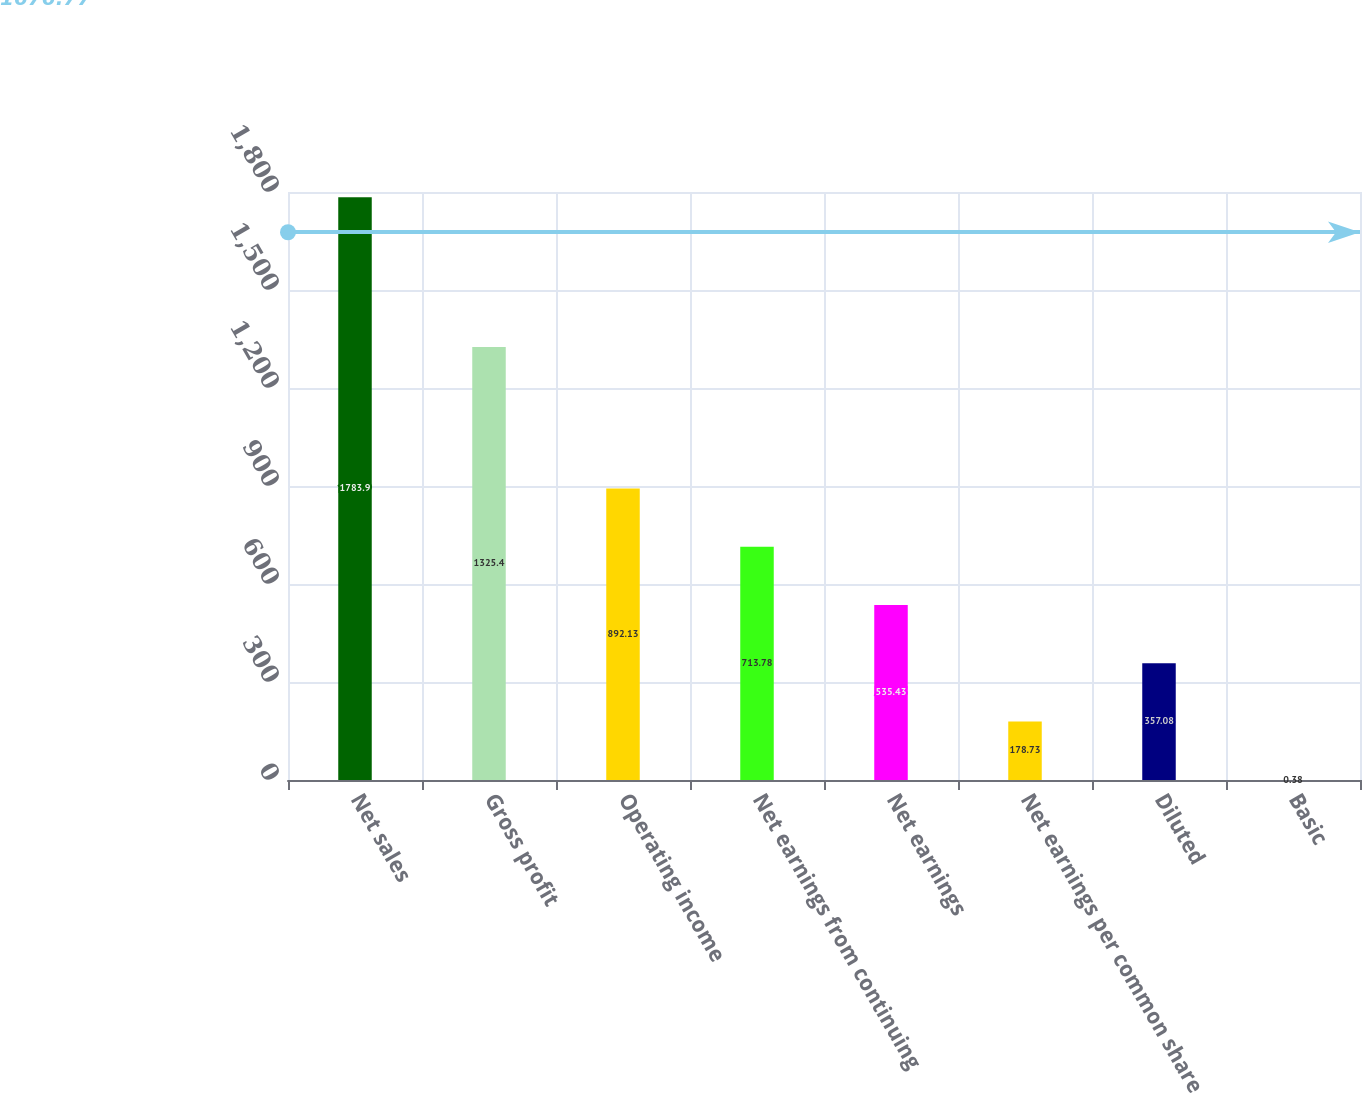Convert chart. <chart><loc_0><loc_0><loc_500><loc_500><bar_chart><fcel>Net sales<fcel>Gross profit<fcel>Operating income<fcel>Net earnings from continuing<fcel>Net earnings<fcel>Net earnings per common share<fcel>Diluted<fcel>Basic<nl><fcel>1783.9<fcel>1325.4<fcel>892.13<fcel>713.78<fcel>535.43<fcel>178.73<fcel>357.08<fcel>0.38<nl></chart> 